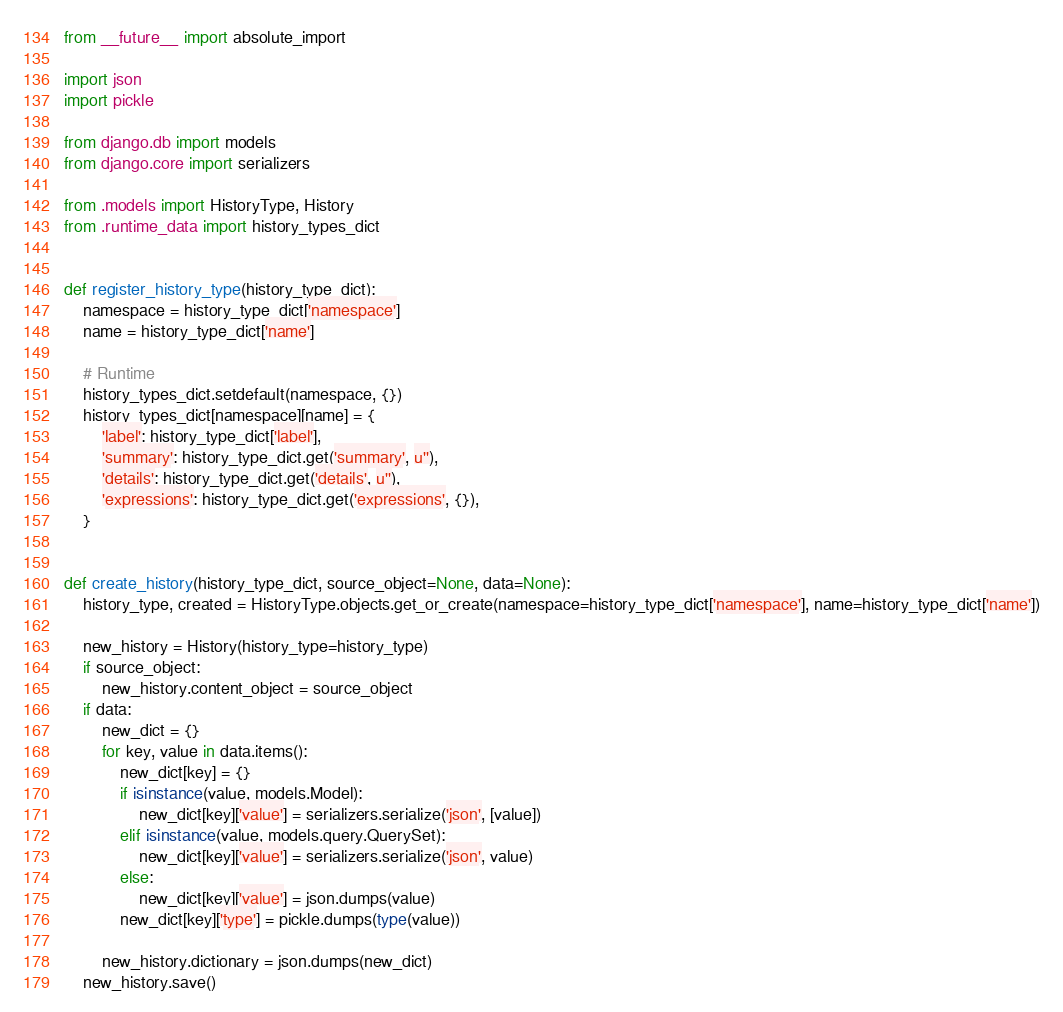Convert code to text. <code><loc_0><loc_0><loc_500><loc_500><_Python_>from __future__ import absolute_import

import json
import pickle

from django.db import models
from django.core import serializers

from .models import HistoryType, History
from .runtime_data import history_types_dict


def register_history_type(history_type_dict):
    namespace = history_type_dict['namespace']
    name = history_type_dict['name']

    # Runtime
    history_types_dict.setdefault(namespace, {})
    history_types_dict[namespace][name] = {
        'label': history_type_dict['label'],
        'summary': history_type_dict.get('summary', u''),
        'details': history_type_dict.get('details', u''),
        'expressions': history_type_dict.get('expressions', {}),
    }


def create_history(history_type_dict, source_object=None, data=None):
    history_type, created = HistoryType.objects.get_or_create(namespace=history_type_dict['namespace'], name=history_type_dict['name'])

    new_history = History(history_type=history_type)
    if source_object:
        new_history.content_object = source_object
    if data:
        new_dict = {}
        for key, value in data.items():
            new_dict[key] = {}
            if isinstance(value, models.Model):
                new_dict[key]['value'] = serializers.serialize('json', [value])
            elif isinstance(value, models.query.QuerySet):
                new_dict[key]['value'] = serializers.serialize('json', value)
            else:
                new_dict[key]['value'] = json.dumps(value)
            new_dict[key]['type'] = pickle.dumps(type(value))

        new_history.dictionary = json.dumps(new_dict)
    new_history.save()
</code> 